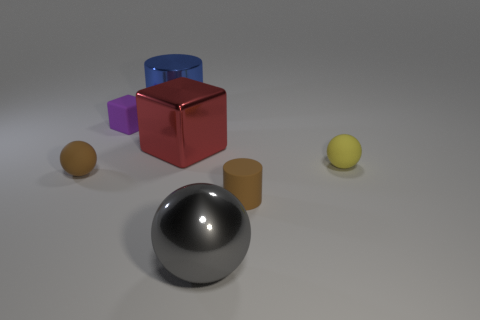What is the size of the gray ball that is in front of the red shiny cube?
Your answer should be compact. Large. The gray metallic thing that is the same size as the blue cylinder is what shape?
Your response must be concise. Sphere. Is the material of the brown thing on the left side of the tiny block the same as the cube on the right side of the big cylinder?
Ensure brevity in your answer.  No. There is a cylinder behind the brown thing on the right side of the big metallic block; what is its material?
Your response must be concise. Metal. There is a red cube right of the rubber ball that is to the left of the brown rubber object that is on the right side of the metallic sphere; how big is it?
Keep it short and to the point. Large. Does the blue object have the same size as the yellow ball?
Offer a terse response. No. Does the metallic object that is behind the large red metal cube have the same shape as the rubber thing behind the red object?
Offer a very short reply. No. Are there any yellow rubber objects that are to the right of the sphere that is in front of the brown matte cylinder?
Offer a very short reply. Yes. Are any tiny cylinders visible?
Your answer should be compact. Yes. What number of blue metallic objects have the same size as the red shiny block?
Your answer should be very brief. 1. 